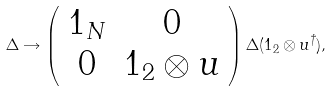Convert formula to latex. <formula><loc_0><loc_0><loc_500><loc_500>\Delta \rightarrow \left ( \begin{array} { c c } 1 _ { N } & 0 \\ 0 & 1 _ { 2 } \otimes u \\ \end{array} \right ) \Delta ( 1 _ { 2 } \otimes u ^ { \dag } ) ,</formula> 